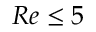Convert formula to latex. <formula><loc_0><loc_0><loc_500><loc_500>R e \leq 5</formula> 